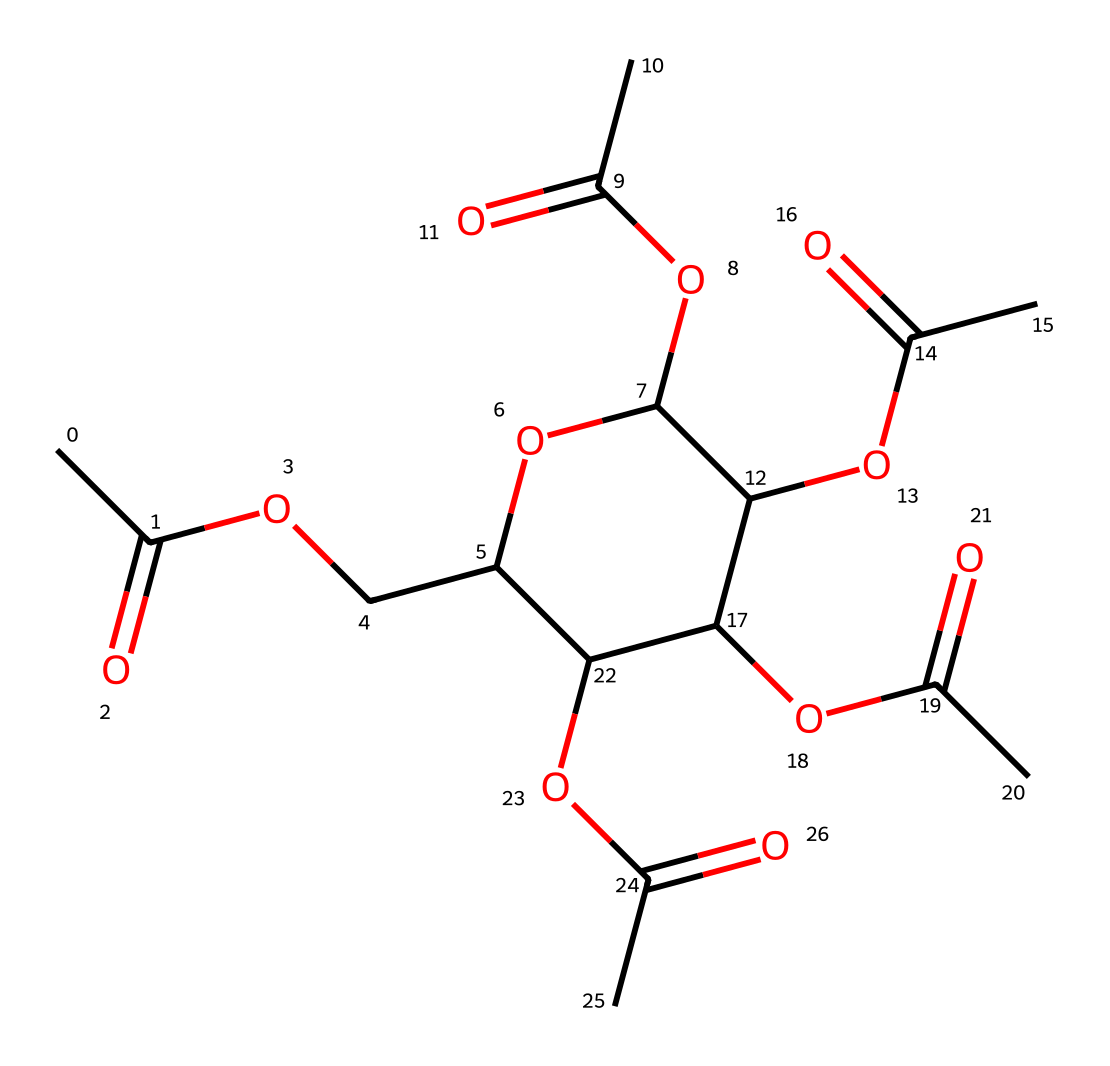What is the main functional group present in cellulose acetate? The chemical structure includes multiple acetate groups (indicated by the CC(=O)O), which are characteristic of acetate functional groups.
Answer: acetate How many acetyl groups are there in the structure? By analyzing the structure, you can see there are five distinct acetate groups attached to the cellulose backbone. This is indicated by the repeated OC(C)=O segments.
Answer: five What type of polymer is cellulose acetate classified as? Cellulose acetate is a thermoplastic polymer, which is determined by its ability to be molded upon heating and its organic polymer nature derived from cellulose.
Answer: thermoplastic Does cellulose acetate contain any cyclic structures? Yes, the structure includes a cyclic ether core, indicated by the presence of the oxygen atom within a ring that connects various acetate groups.
Answer: yes What is the significance of the presence of acetate groups in biodegradable packaging? The presence of acetate groups enhances the biodegradability of the polymer, as they are more easily broken down by microbial action compared to other functional groups in traditional plastics.
Answer: biodegradability Is the cellulose acetate structure branched or linear? The structure is branched, characterized by the multiple branching points where the acetate groups bond to a central cyclic structure.
Answer: branched 